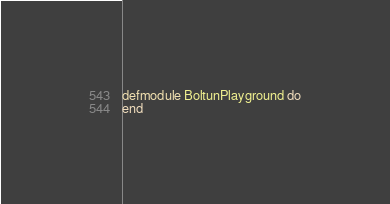<code> <loc_0><loc_0><loc_500><loc_500><_Elixir_>defmodule BoltunPlayground do
end
</code> 